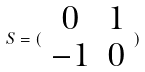<formula> <loc_0><loc_0><loc_500><loc_500>S = ( \begin{array} { c c } 0 & 1 \\ - 1 & 0 \end{array} )</formula> 